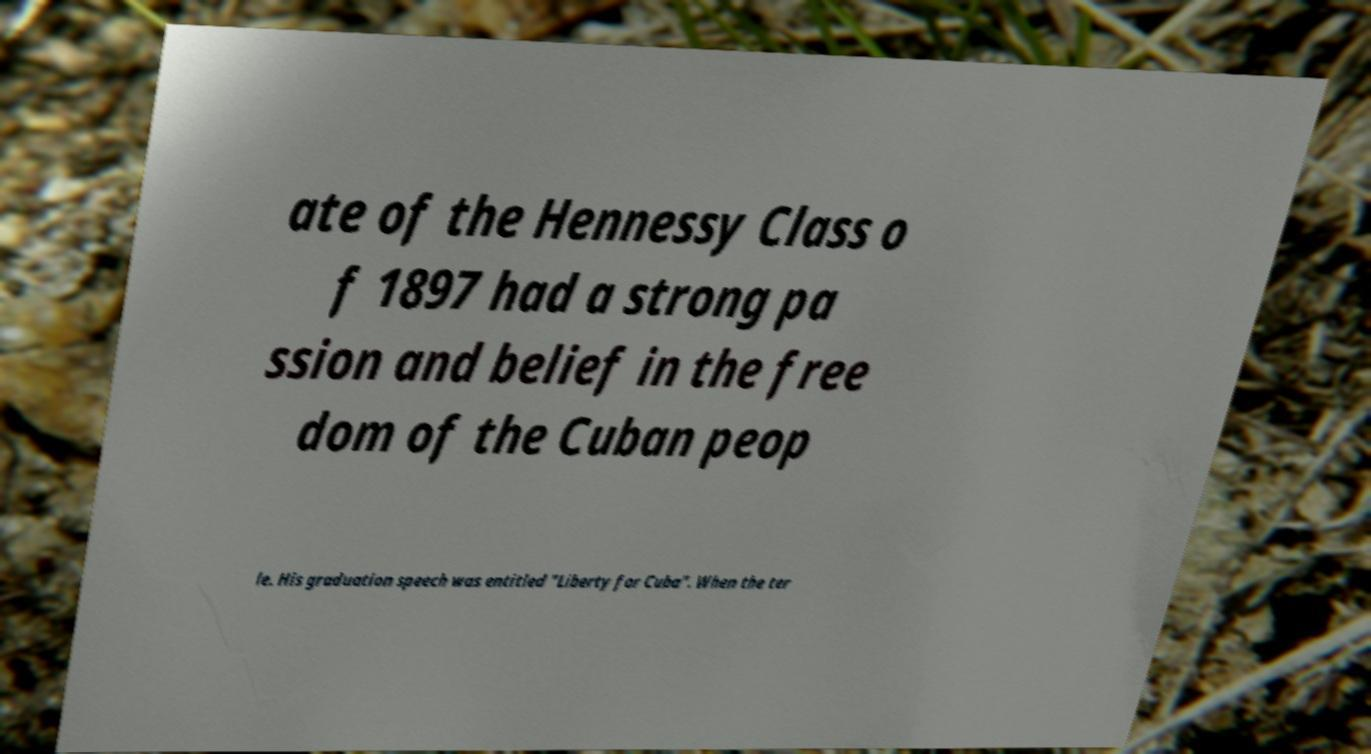Can you read and provide the text displayed in the image?This photo seems to have some interesting text. Can you extract and type it out for me? ate of the Hennessy Class o f 1897 had a strong pa ssion and belief in the free dom of the Cuban peop le. His graduation speech was entitled "Liberty for Cuba". When the ter 